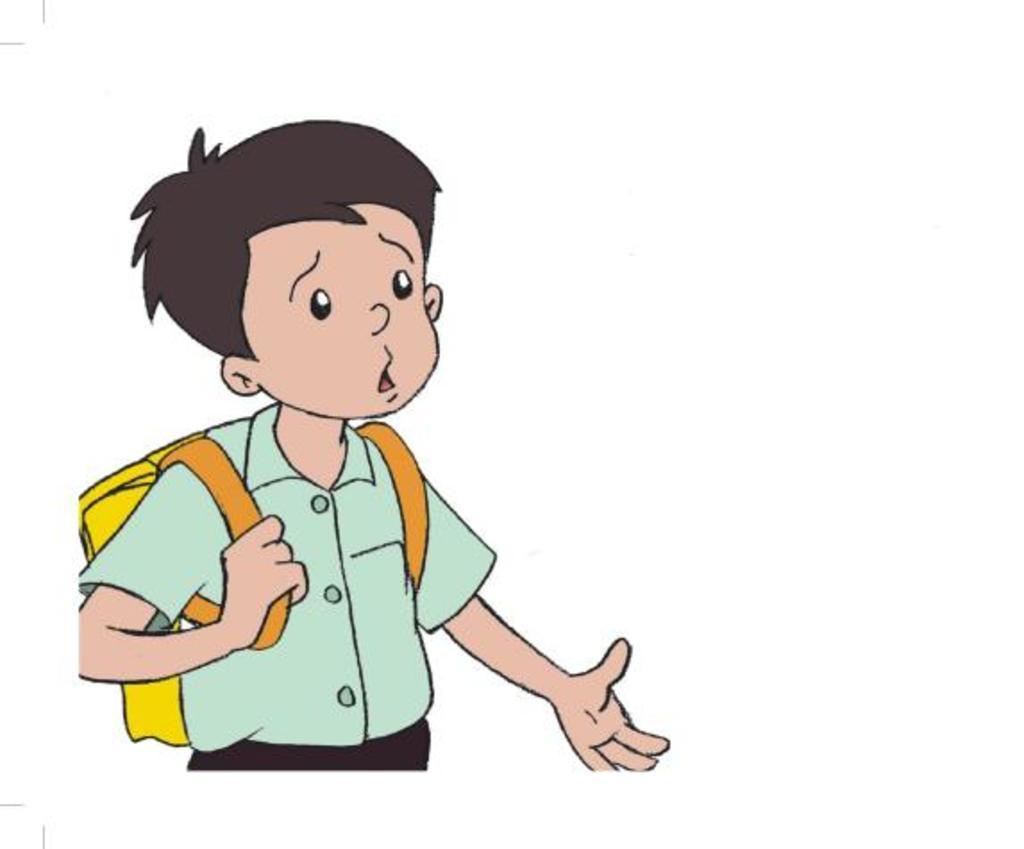Could you give a brief overview of what you see in this image? In this picture I can see cartoon image of a boy wore a school bag and I can see white color background. 